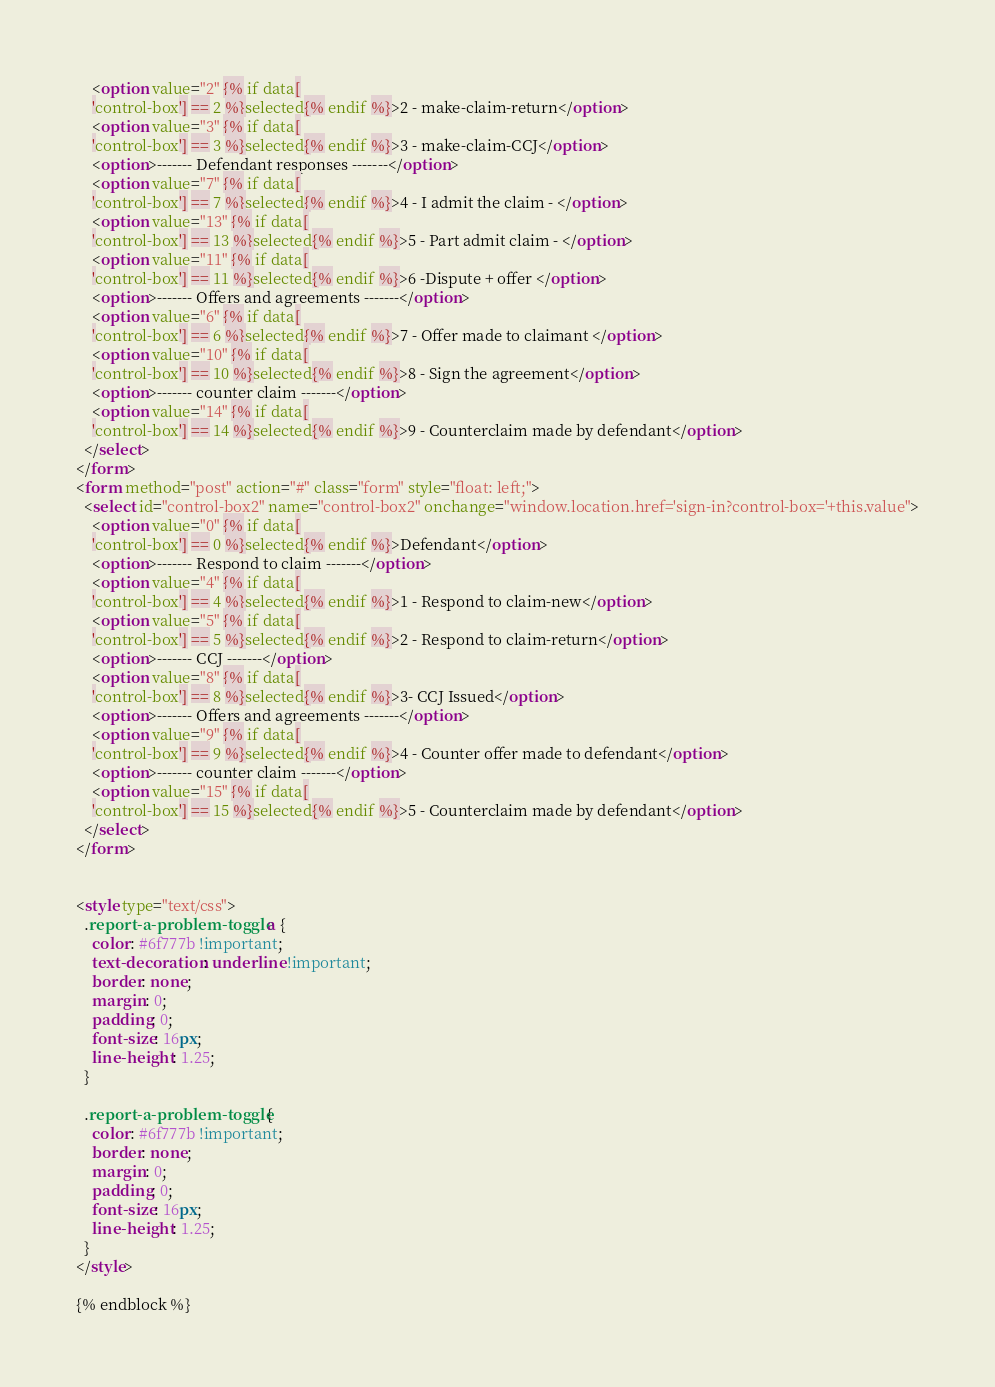Convert code to text. <code><loc_0><loc_0><loc_500><loc_500><_HTML_>    <option value="2" {% if data[
    'control-box'] == 2 %}selected{% endif %}>2 - make-claim-return</option>
    <option value="3" {% if data[
    'control-box'] == 3 %}selected{% endif %}>3 - make-claim-CCJ</option>
    <option>------- Defendant responses -------</option>
    <option value="7" {% if data[
    'control-box'] == 7 %}selected{% endif %}>4 - I admit the claim - </option>
    <option value="13" {% if data[
    'control-box'] == 13 %}selected{% endif %}>5 - Part admit claim - </option>
    <option value="11" {% if data[
    'control-box'] == 11 %}selected{% endif %}>6 -Dispute + offer </option>
    <option>------- Offers and agreements -------</option>
    <option value="6" {% if data[
    'control-box'] == 6 %}selected{% endif %}>7 - Offer made to claimant </option>
    <option value="10" {% if data[
    'control-box'] == 10 %}selected{% endif %}>8 - Sign the agreement</option>
    <option>------- counter claim -------</option>
    <option value="14" {% if data[
    'control-box'] == 14 %}selected{% endif %}>9 - Counterclaim made by defendant</option>
  </select>
</form>
<form method="post" action="#" class="form" style="float: left;">
  <select id="control-box2" name="control-box2" onchange="window.location.href='sign-in?control-box='+this.value">
    <option value="0" {% if data[
    'control-box'] == 0 %}selected{% endif %}>Defendant</option>
    <option>------- Respond to claim -------</option>
    <option value="4" {% if data[
    'control-box'] == 4 %}selected{% endif %}>1 - Respond to claim-new</option>
    <option value="5" {% if data[
    'control-box'] == 5 %}selected{% endif %}>2 - Respond to claim-return</option>
    <option>------- CCJ -------</option>
    <option value="8" {% if data[
    'control-box'] == 8 %}selected{% endif %}>3- CCJ Issued</option>
    <option>------- Offers and agreements -------</option>
    <option value="9" {% if data[
    'control-box'] == 9 %}selected{% endif %}>4 - Counter offer made to defendant</option>
    <option>------- counter claim -------</option>
    <option value="15" {% if data[
    'control-box'] == 15 %}selected{% endif %}>5 - Counterclaim made by defendant</option>
  </select>
</form>


<style type="text/css">
  .report-a-problem-toggle a {
    color: #6f777b !important;
    text-decoration: underline !important;
    border: none;
    margin: 0;
    padding: 0;
    font-size: 16px;
    line-height: 1.25;
  }

  .report-a-problem-toggle {
    color: #6f777b !important;
    border: none;
    margin: 0;
    padding: 0;
    font-size: 16px;
    line-height: 1.25;
  }
</style>

{% endblock %}
</code> 